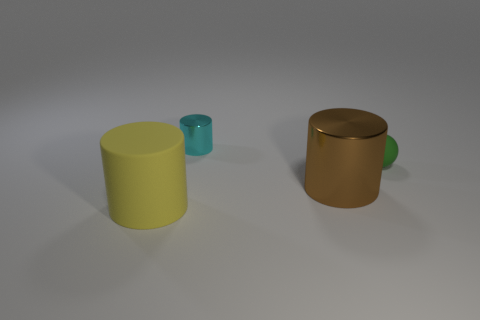Add 2 small rubber things. How many objects exist? 6 Subtract all cyan cylinders. How many cylinders are left? 2 Subtract all metallic cylinders. How many cylinders are left? 1 Subtract all cylinders. How many objects are left? 1 Subtract 1 balls. How many balls are left? 0 Add 3 tiny blue blocks. How many tiny blue blocks exist? 3 Subtract 0 brown spheres. How many objects are left? 4 Subtract all red cylinders. Subtract all red balls. How many cylinders are left? 3 Subtract all red cubes. How many brown cylinders are left? 1 Subtract all brown metal things. Subtract all big cyan objects. How many objects are left? 3 